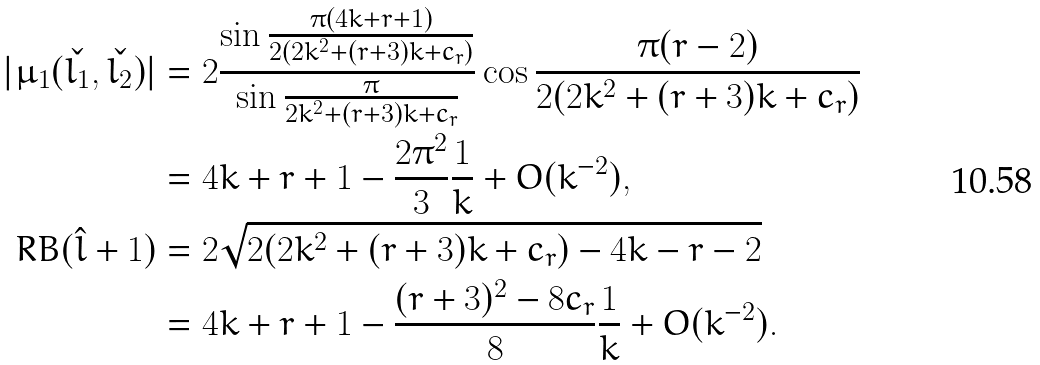<formula> <loc_0><loc_0><loc_500><loc_500>| \mu _ { 1 } ( \check { l _ { 1 } } , \check { l _ { 2 } } ) | & = 2 \frac { \sin { \frac { \pi ( 4 k + r + 1 ) } { 2 ( 2 k ^ { 2 } + ( r + 3 ) k + c _ { r } ) } } } { \sin { \frac { \pi } { 2 k ^ { 2 } + ( r + 3 ) k + c _ { r } } } } \cos { \frac { \pi ( r - 2 ) } { 2 ( 2 k ^ { 2 } + ( r + 3 ) k + c _ { r } ) } } \\ & = 4 k + r + 1 - \frac { 2 \pi ^ { 2 } } { 3 } \frac { 1 } { k } + O ( k ^ { - 2 } ) , \\ R B ( \hat { l } + 1 ) & = 2 \sqrt { 2 ( 2 k ^ { 2 } + ( r + 3 ) k + c _ { r } ) - 4 k - r - 2 } \\ & = 4 k + r + 1 - \frac { ( r + 3 ) ^ { 2 } - 8 c _ { r } } { 8 } \frac { 1 } { k } + O ( k ^ { - 2 } ) .</formula> 